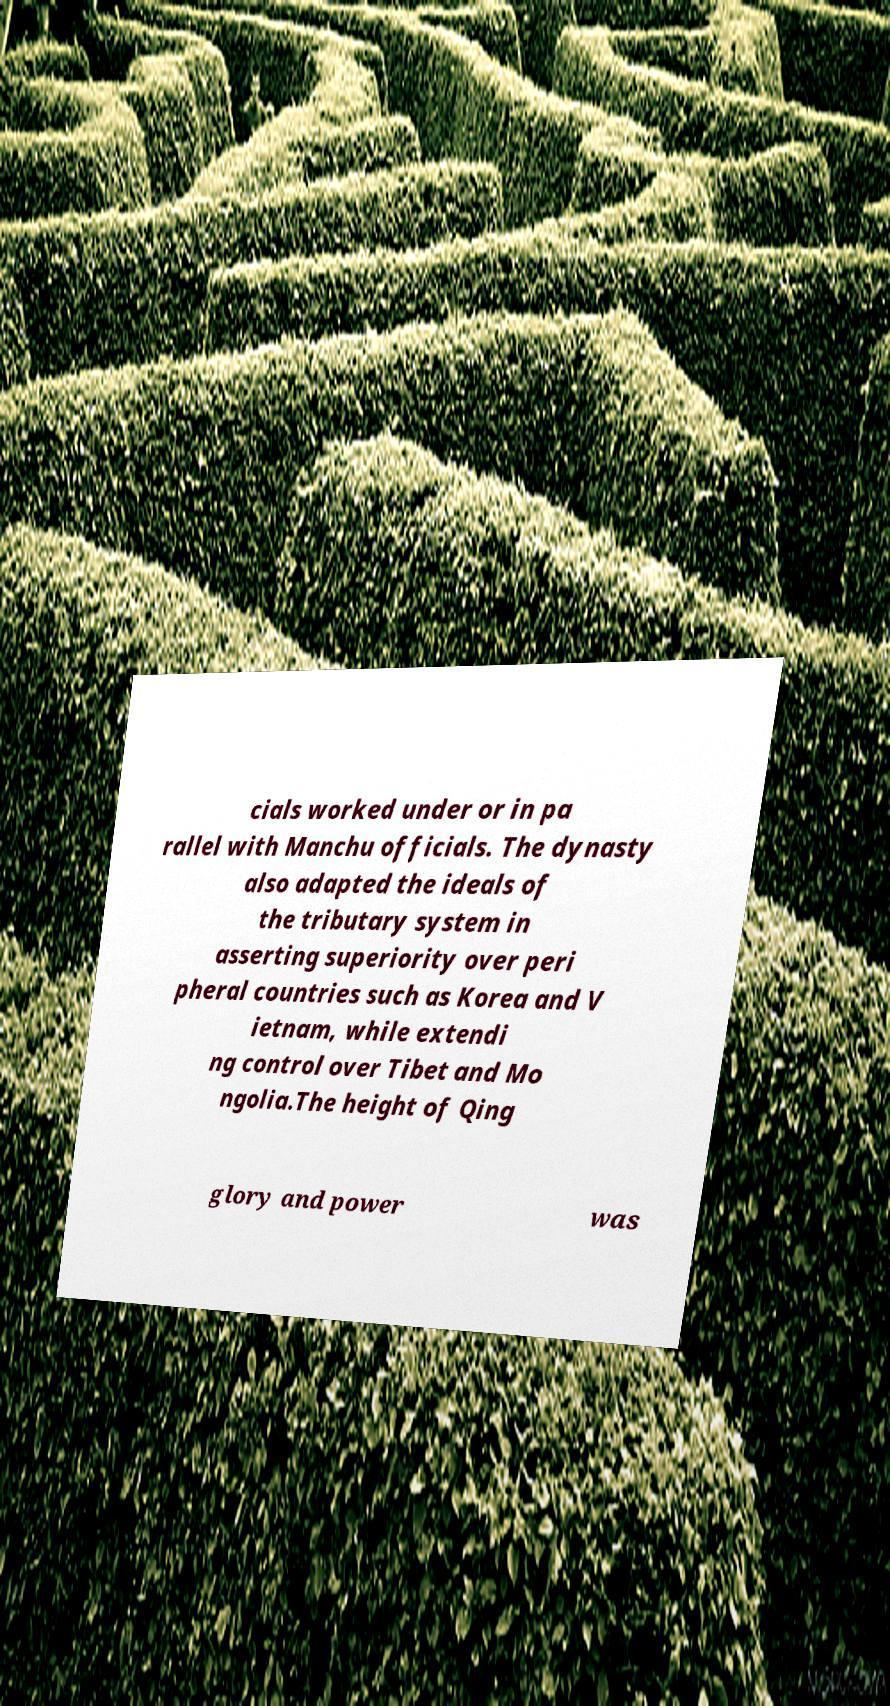What messages or text are displayed in this image? I need them in a readable, typed format. cials worked under or in pa rallel with Manchu officials. The dynasty also adapted the ideals of the tributary system in asserting superiority over peri pheral countries such as Korea and V ietnam, while extendi ng control over Tibet and Mo ngolia.The height of Qing glory and power was 